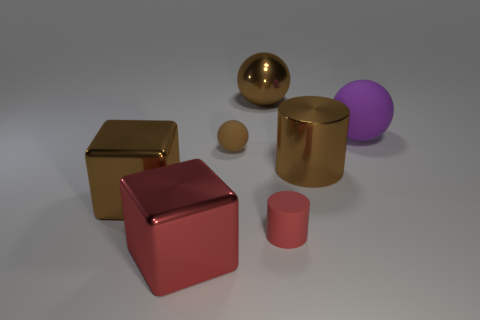What could be the purpose of arranging these objects like this? This arrangement of geometric shapes and different textures can serve educational purposes, such as demonstrating the properties of light and materials in 3D rendering. Moreover, it could be an artistic composition, focusing on form, balance, and contrast to create a visually appealing scene. 